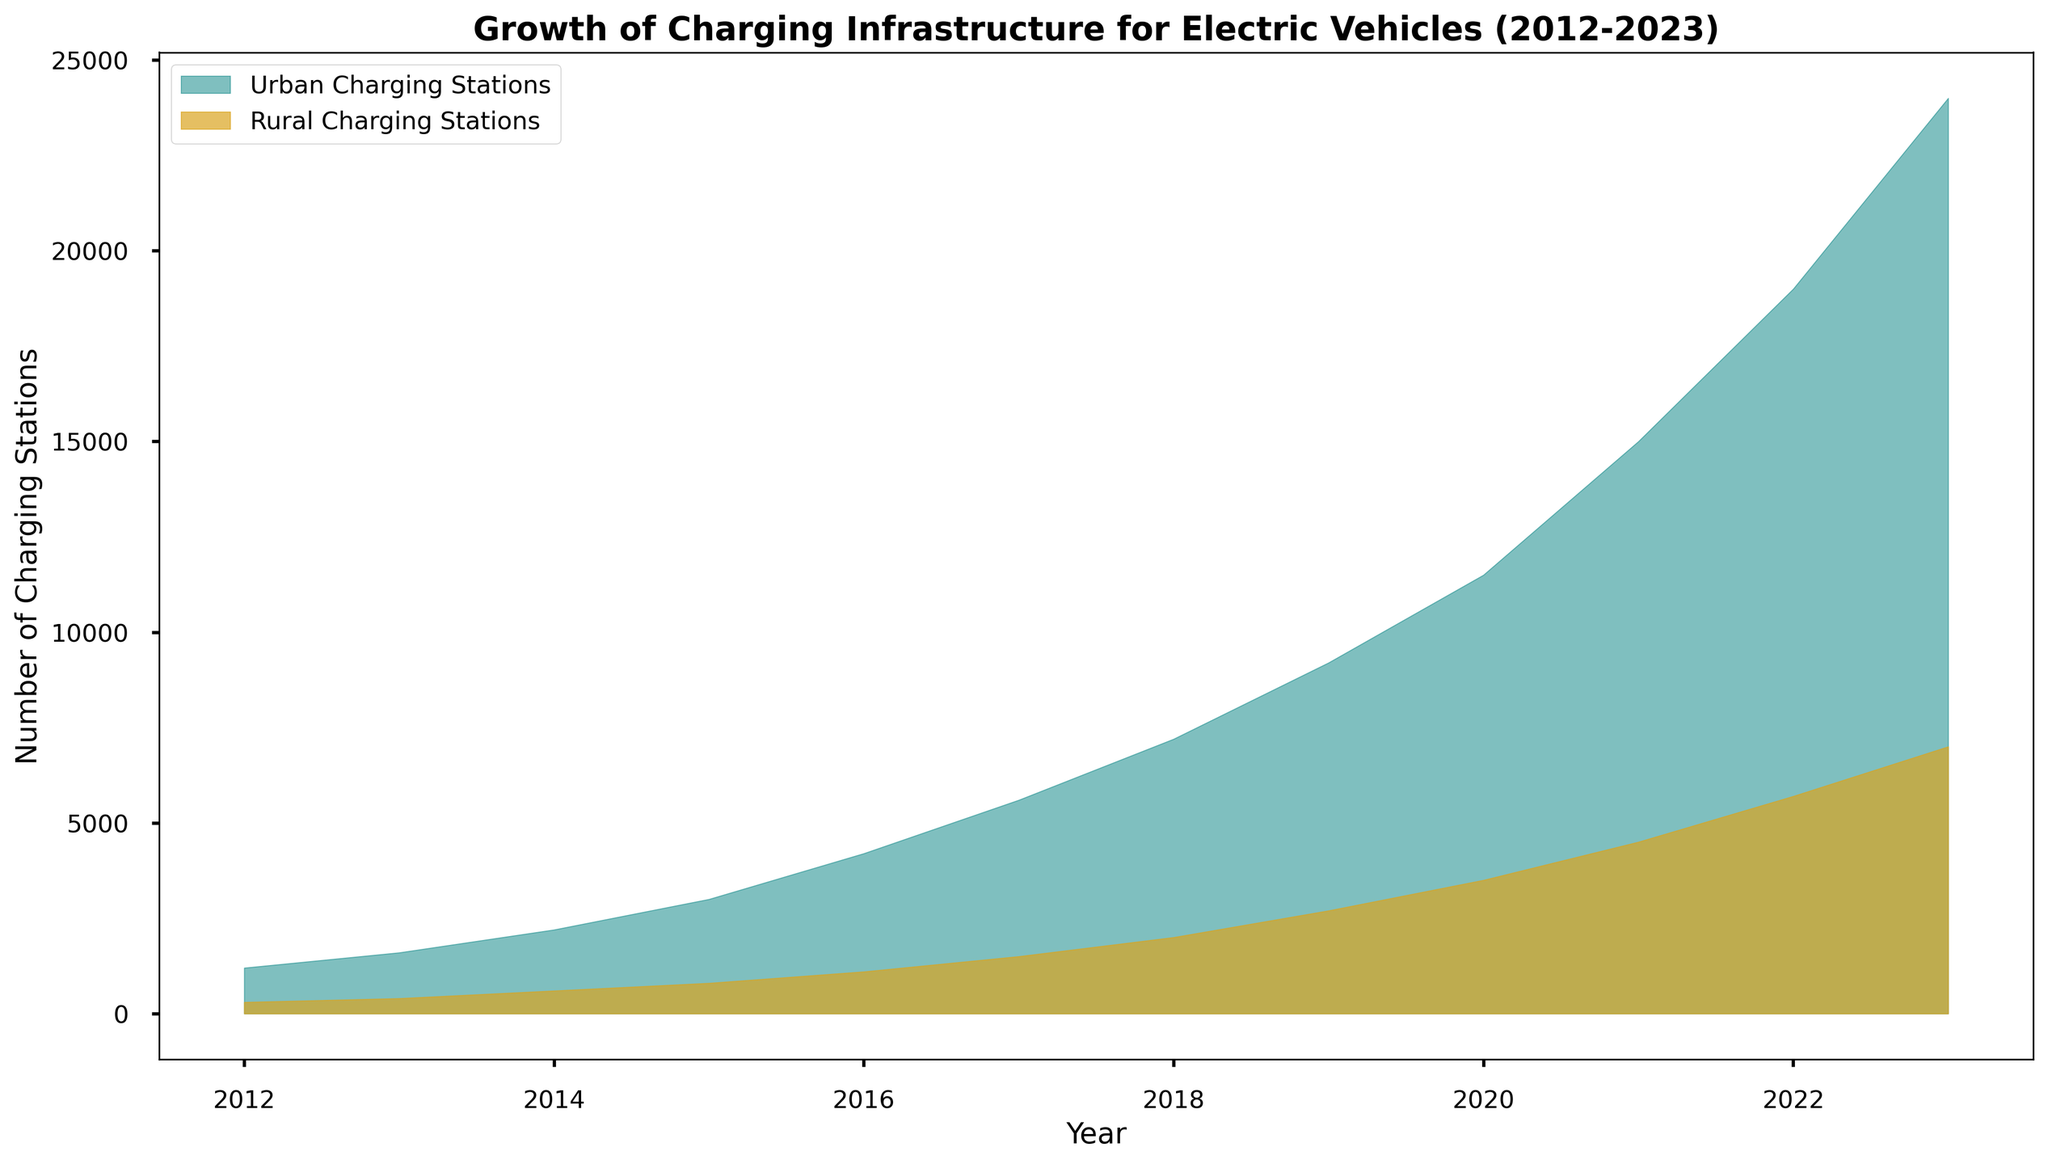What's the total number of urban and rural charging stations in 2023? For urban, the value visualized is 24000, and for rural, it is 7000. Summing these gives 24000 + 7000 = 31000.
Answer: 31000 Which type of area (urban or rural) had a greater increase in charging stations from 2012 to 2023? In 2012, urban had 1200 and rural had 300. By 2023, urban had 24000 and rural had 7000. The increase for urban is 24000 - 1200 = 22800. For rural, the increase is 7000 - 300 = 6700. Urban had a greater increase.
Answer: Urban What year did urban charging stations reach 10000? Looking at the urban curve, it reaches and surpasses 10000 between 2019 and 2020. Hence, the year urban charging stations reached 10000 is 2020.
Answer: 2020 How many more charging stations were there in urban areas compared to rural areas in 2016? In 2016, urban had 4200 stations, and rural had 1100 stations. So, the difference is 4200 - 1100 = 3100.
Answer: 3100 What is the average number of rural charging stations over the period 2012-2023? Sum the rural values: 300 + 400 + 600 + 800 + 1100 + 1500 + 2000 + 2700 + 3500 + 4500 + 5700 + 7000 = 30100. Average over 12 years: 30100 / 12 = 2508.33.
Answer: 2508.33 In what year did the number of rural charging stations reach half the number of urban charging stations? The value of urban stations in 2019 is 9200. Half of that is 4600. The graph shows rural stations reached 4500 in 2021. 2021 is closest to half of 9200 but slightly below it.
Answer: 2021 Which year showed the highest yearly increase in the number of rural charging stations? Calculate year-to-year differences: 400-300=100, 600-400=200, 800-600=200, 1100-800=300, 1500-1100=400, 2000-1500=500, 2700-2000=700, 3500-2700=800, 4500-3500=1000, 5700-4500=1200, 7000-5700=1300. The highest increase is from 2022 to 2023, which is 1300.
Answer: 2023 In which year did the urban area add the most new charging stations? Calculate the yearly differences for urban: 1600-1200=400, 2200-1600=600, 3000-2200=800, 4200-3000=1200, 5600-4200=1400, 7200-5600=1600, 9200-7200=2000, 11500-9200=2300, 15000-11500=3500, 19000-15000=4000, 24000-19000=5000. The highest addition is 2022 to 2023 with 5000 new stations.
Answer: 2023 When did rural charging stations first exceed 1000? Refer to the graph and see that rural charging stations first exceeded 1000 in 2016.
Answer: 2016 